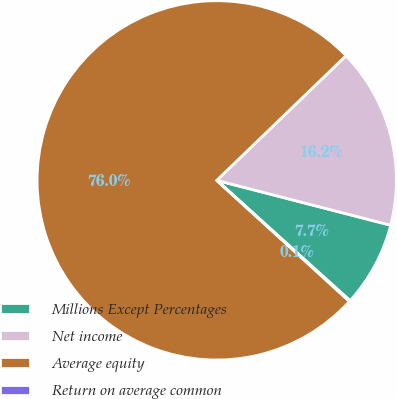<chart> <loc_0><loc_0><loc_500><loc_500><pie_chart><fcel>Millions Except Percentages<fcel>Net income<fcel>Average equity<fcel>Return on average common<nl><fcel>7.67%<fcel>16.23%<fcel>76.02%<fcel>0.08%<nl></chart> 